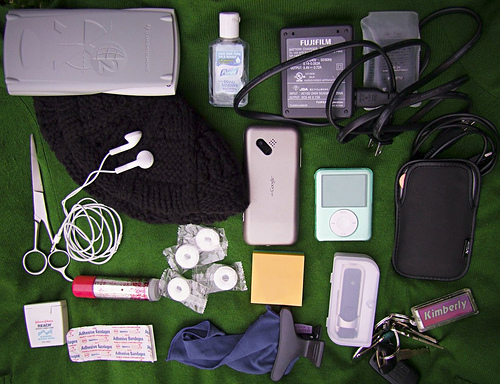Please transcribe the text in this image. kimberly 